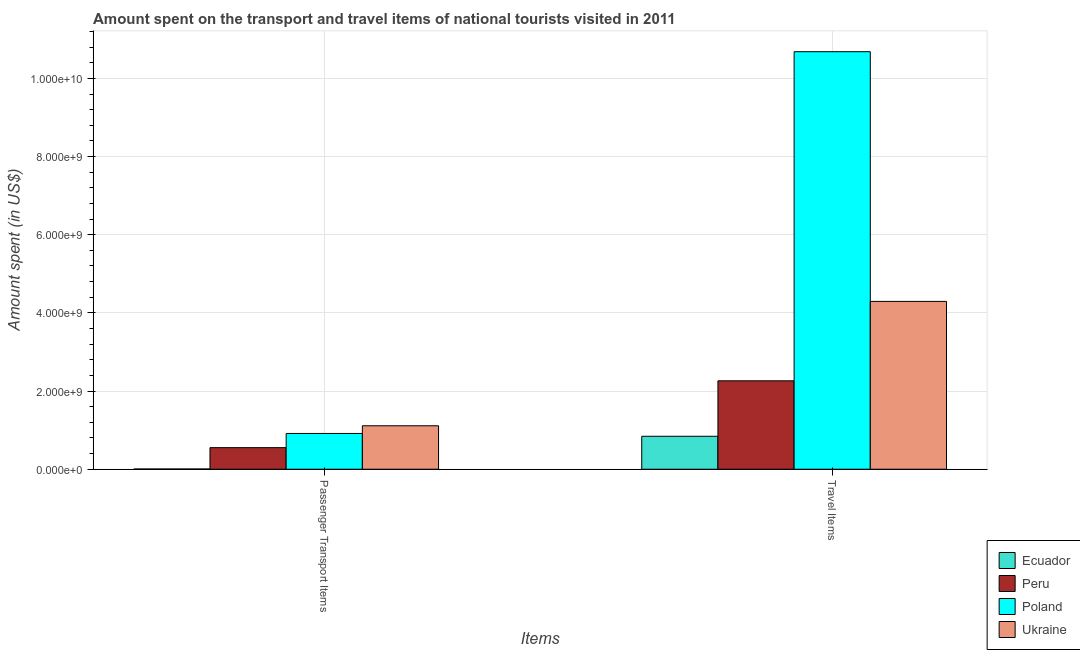How many different coloured bars are there?
Provide a succinct answer. 4. Are the number of bars on each tick of the X-axis equal?
Give a very brief answer. Yes. How many bars are there on the 1st tick from the right?
Your answer should be compact. 4. What is the label of the 1st group of bars from the left?
Make the answer very short. Passenger Transport Items. What is the amount spent in travel items in Poland?
Offer a terse response. 1.07e+1. Across all countries, what is the maximum amount spent in travel items?
Offer a very short reply. 1.07e+1. Across all countries, what is the minimum amount spent on passenger transport items?
Keep it short and to the point. 6.00e+06. In which country was the amount spent on passenger transport items maximum?
Give a very brief answer. Ukraine. In which country was the amount spent on passenger transport items minimum?
Ensure brevity in your answer.  Ecuador. What is the total amount spent on passenger transport items in the graph?
Keep it short and to the point. 2.58e+09. What is the difference between the amount spent on passenger transport items in Poland and that in Ecuador?
Keep it short and to the point. 9.09e+08. What is the difference between the amount spent on passenger transport items in Poland and the amount spent in travel items in Peru?
Your response must be concise. -1.35e+09. What is the average amount spent in travel items per country?
Ensure brevity in your answer.  4.52e+09. What is the difference between the amount spent in travel items and amount spent on passenger transport items in Poland?
Your response must be concise. 9.77e+09. In how many countries, is the amount spent on passenger transport items greater than 7200000000 US$?
Provide a succinct answer. 0. What is the ratio of the amount spent on passenger transport items in Ukraine to that in Peru?
Your response must be concise. 2.01. In how many countries, is the amount spent on passenger transport items greater than the average amount spent on passenger transport items taken over all countries?
Offer a terse response. 2. What does the 1st bar from the left in Passenger Transport Items represents?
Offer a very short reply. Ecuador. What does the 1st bar from the right in Travel Items represents?
Your answer should be compact. Ukraine. How many bars are there?
Make the answer very short. 8. How many countries are there in the graph?
Your answer should be very brief. 4. Are the values on the major ticks of Y-axis written in scientific E-notation?
Offer a terse response. Yes. Does the graph contain any zero values?
Your answer should be compact. No. Does the graph contain grids?
Your answer should be very brief. Yes. How many legend labels are there?
Your response must be concise. 4. How are the legend labels stacked?
Make the answer very short. Vertical. What is the title of the graph?
Your answer should be compact. Amount spent on the transport and travel items of national tourists visited in 2011. What is the label or title of the X-axis?
Keep it short and to the point. Items. What is the label or title of the Y-axis?
Give a very brief answer. Amount spent (in US$). What is the Amount spent (in US$) in Peru in Passenger Transport Items?
Provide a succinct answer. 5.52e+08. What is the Amount spent (in US$) of Poland in Passenger Transport Items?
Offer a terse response. 9.15e+08. What is the Amount spent (in US$) in Ukraine in Passenger Transport Items?
Your response must be concise. 1.11e+09. What is the Amount spent (in US$) in Ecuador in Travel Items?
Ensure brevity in your answer.  8.43e+08. What is the Amount spent (in US$) of Peru in Travel Items?
Give a very brief answer. 2.26e+09. What is the Amount spent (in US$) of Poland in Travel Items?
Offer a very short reply. 1.07e+1. What is the Amount spent (in US$) of Ukraine in Travel Items?
Ensure brevity in your answer.  4.29e+09. Across all Items, what is the maximum Amount spent (in US$) in Ecuador?
Give a very brief answer. 8.43e+08. Across all Items, what is the maximum Amount spent (in US$) in Peru?
Provide a short and direct response. 2.26e+09. Across all Items, what is the maximum Amount spent (in US$) of Poland?
Give a very brief answer. 1.07e+1. Across all Items, what is the maximum Amount spent (in US$) in Ukraine?
Ensure brevity in your answer.  4.29e+09. Across all Items, what is the minimum Amount spent (in US$) in Peru?
Give a very brief answer. 5.52e+08. Across all Items, what is the minimum Amount spent (in US$) of Poland?
Ensure brevity in your answer.  9.15e+08. Across all Items, what is the minimum Amount spent (in US$) of Ukraine?
Ensure brevity in your answer.  1.11e+09. What is the total Amount spent (in US$) in Ecuador in the graph?
Your answer should be compact. 8.49e+08. What is the total Amount spent (in US$) of Peru in the graph?
Your response must be concise. 2.81e+09. What is the total Amount spent (in US$) of Poland in the graph?
Keep it short and to the point. 1.16e+1. What is the total Amount spent (in US$) in Ukraine in the graph?
Keep it short and to the point. 5.41e+09. What is the difference between the Amount spent (in US$) in Ecuador in Passenger Transport Items and that in Travel Items?
Your response must be concise. -8.37e+08. What is the difference between the Amount spent (in US$) in Peru in Passenger Transport Items and that in Travel Items?
Provide a succinct answer. -1.71e+09. What is the difference between the Amount spent (in US$) of Poland in Passenger Transport Items and that in Travel Items?
Make the answer very short. -9.77e+09. What is the difference between the Amount spent (in US$) of Ukraine in Passenger Transport Items and that in Travel Items?
Provide a succinct answer. -3.18e+09. What is the difference between the Amount spent (in US$) in Ecuador in Passenger Transport Items and the Amount spent (in US$) in Peru in Travel Items?
Make the answer very short. -2.26e+09. What is the difference between the Amount spent (in US$) of Ecuador in Passenger Transport Items and the Amount spent (in US$) of Poland in Travel Items?
Ensure brevity in your answer.  -1.07e+1. What is the difference between the Amount spent (in US$) of Ecuador in Passenger Transport Items and the Amount spent (in US$) of Ukraine in Travel Items?
Your answer should be very brief. -4.29e+09. What is the difference between the Amount spent (in US$) of Peru in Passenger Transport Items and the Amount spent (in US$) of Poland in Travel Items?
Provide a short and direct response. -1.01e+1. What is the difference between the Amount spent (in US$) in Peru in Passenger Transport Items and the Amount spent (in US$) in Ukraine in Travel Items?
Ensure brevity in your answer.  -3.74e+09. What is the difference between the Amount spent (in US$) of Poland in Passenger Transport Items and the Amount spent (in US$) of Ukraine in Travel Items?
Your answer should be compact. -3.38e+09. What is the average Amount spent (in US$) in Ecuador per Items?
Provide a short and direct response. 4.24e+08. What is the average Amount spent (in US$) in Peru per Items?
Your answer should be very brief. 1.41e+09. What is the average Amount spent (in US$) of Poland per Items?
Your answer should be compact. 5.80e+09. What is the average Amount spent (in US$) in Ukraine per Items?
Offer a terse response. 2.70e+09. What is the difference between the Amount spent (in US$) in Ecuador and Amount spent (in US$) in Peru in Passenger Transport Items?
Provide a succinct answer. -5.46e+08. What is the difference between the Amount spent (in US$) in Ecuador and Amount spent (in US$) in Poland in Passenger Transport Items?
Offer a terse response. -9.09e+08. What is the difference between the Amount spent (in US$) of Ecuador and Amount spent (in US$) of Ukraine in Passenger Transport Items?
Provide a short and direct response. -1.11e+09. What is the difference between the Amount spent (in US$) in Peru and Amount spent (in US$) in Poland in Passenger Transport Items?
Provide a short and direct response. -3.63e+08. What is the difference between the Amount spent (in US$) of Peru and Amount spent (in US$) of Ukraine in Passenger Transport Items?
Make the answer very short. -5.60e+08. What is the difference between the Amount spent (in US$) of Poland and Amount spent (in US$) of Ukraine in Passenger Transport Items?
Your answer should be compact. -1.97e+08. What is the difference between the Amount spent (in US$) of Ecuador and Amount spent (in US$) of Peru in Travel Items?
Offer a very short reply. -1.42e+09. What is the difference between the Amount spent (in US$) of Ecuador and Amount spent (in US$) of Poland in Travel Items?
Provide a short and direct response. -9.84e+09. What is the difference between the Amount spent (in US$) of Ecuador and Amount spent (in US$) of Ukraine in Travel Items?
Ensure brevity in your answer.  -3.45e+09. What is the difference between the Amount spent (in US$) of Peru and Amount spent (in US$) of Poland in Travel Items?
Ensure brevity in your answer.  -8.42e+09. What is the difference between the Amount spent (in US$) in Peru and Amount spent (in US$) in Ukraine in Travel Items?
Offer a very short reply. -2.03e+09. What is the difference between the Amount spent (in US$) of Poland and Amount spent (in US$) of Ukraine in Travel Items?
Provide a succinct answer. 6.39e+09. What is the ratio of the Amount spent (in US$) in Ecuador in Passenger Transport Items to that in Travel Items?
Give a very brief answer. 0.01. What is the ratio of the Amount spent (in US$) of Peru in Passenger Transport Items to that in Travel Items?
Your answer should be very brief. 0.24. What is the ratio of the Amount spent (in US$) of Poland in Passenger Transport Items to that in Travel Items?
Your answer should be compact. 0.09. What is the ratio of the Amount spent (in US$) of Ukraine in Passenger Transport Items to that in Travel Items?
Offer a terse response. 0.26. What is the difference between the highest and the second highest Amount spent (in US$) in Ecuador?
Your answer should be compact. 8.37e+08. What is the difference between the highest and the second highest Amount spent (in US$) of Peru?
Keep it short and to the point. 1.71e+09. What is the difference between the highest and the second highest Amount spent (in US$) of Poland?
Keep it short and to the point. 9.77e+09. What is the difference between the highest and the second highest Amount spent (in US$) in Ukraine?
Keep it short and to the point. 3.18e+09. What is the difference between the highest and the lowest Amount spent (in US$) of Ecuador?
Your response must be concise. 8.37e+08. What is the difference between the highest and the lowest Amount spent (in US$) of Peru?
Offer a terse response. 1.71e+09. What is the difference between the highest and the lowest Amount spent (in US$) in Poland?
Offer a very short reply. 9.77e+09. What is the difference between the highest and the lowest Amount spent (in US$) of Ukraine?
Your answer should be compact. 3.18e+09. 